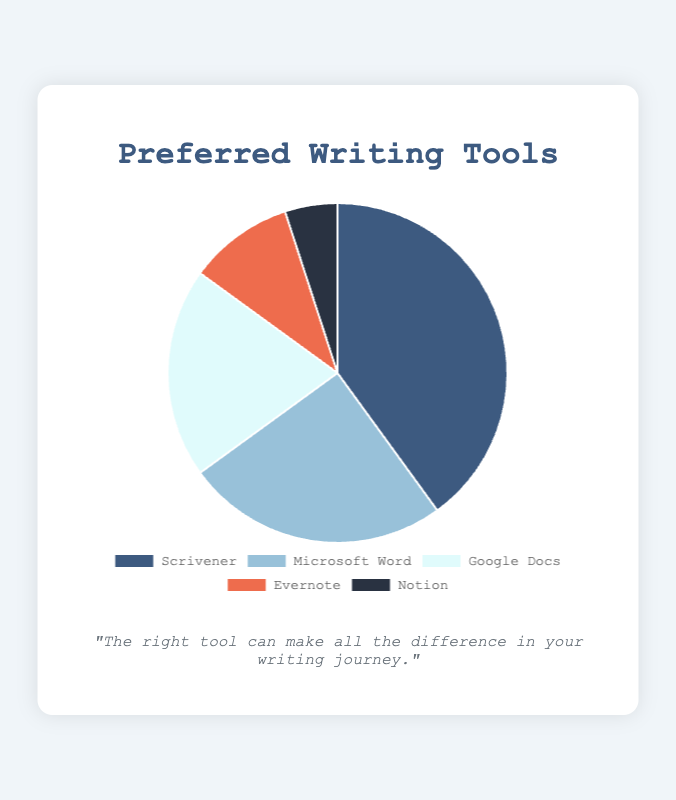What's the most preferred writing tool? The tool with the highest percentage is the most preferred one. According to the pie chart, 'Scrivener' has the highest percentage with 40%.
Answer: Scrivener Which writing tool is used by 20% of people? To find the tool used by 20% of people, look for the segment of the pie chart labeled with 20%. 'Google Docs' is the tool corresponding to 20%.
Answer: Google Docs How much more popular is Scrivener compared to Notion? Scrivener is at 40%, and Notion is at 5%. Subtract the percentage of Notion from Scrivener: 40% - 5% = 35%.
Answer: 35% Which writing tool has the smallest segment in the pie chart? The smallest segment will represent the lowest percentage, which is 5%. 'Notion' corresponds to this smallest segment.
Answer: Notion What is the combined percentage of people using Evernote and Notion? Evernote is at 10% and Notion is at 5%. Add their percentages together: 10% + 5% = 15%.
Answer: 15% Is Microsoft Word preferred over Google Docs, and by how much? Microsoft Word has 25% and Google Docs has 20%. Subtract the percentage of Google Docs from Microsoft Word: 25% - 20% = 5%.
Answer: Yes, by 5% What color represents Scrivener on the pie chart? Identify the color of the segment labeled 'Scrivener' in the pie chart, which is dark blue.
Answer: Dark blue Which tools collectively account for 30% of the preferences? Evernote is at 10% and Notion is at 5%, together making 15%. Adding Google Docs at 20% exceeds 30%. Thus, Evernote (10%) and Google Docs (20%) together account for 30%.
Answer: Evernote and Google Docs What is the average percentage for Microsoft Word, Google Docs, and Evernote? Sum the percentages of these tools: 25% (Microsoft Word) + 20% (Google Docs) + 10% (Evernote) = 55%. Then divide by the number of tools: 55% / 3 ≈ 18.33%.
Answer: 18.33% Which writing tool is represented by a light blue color? Identify the light blue segment of the pie chart. The color light blue corresponds to 'Microsoft Word'.
Answer: Microsoft Word 